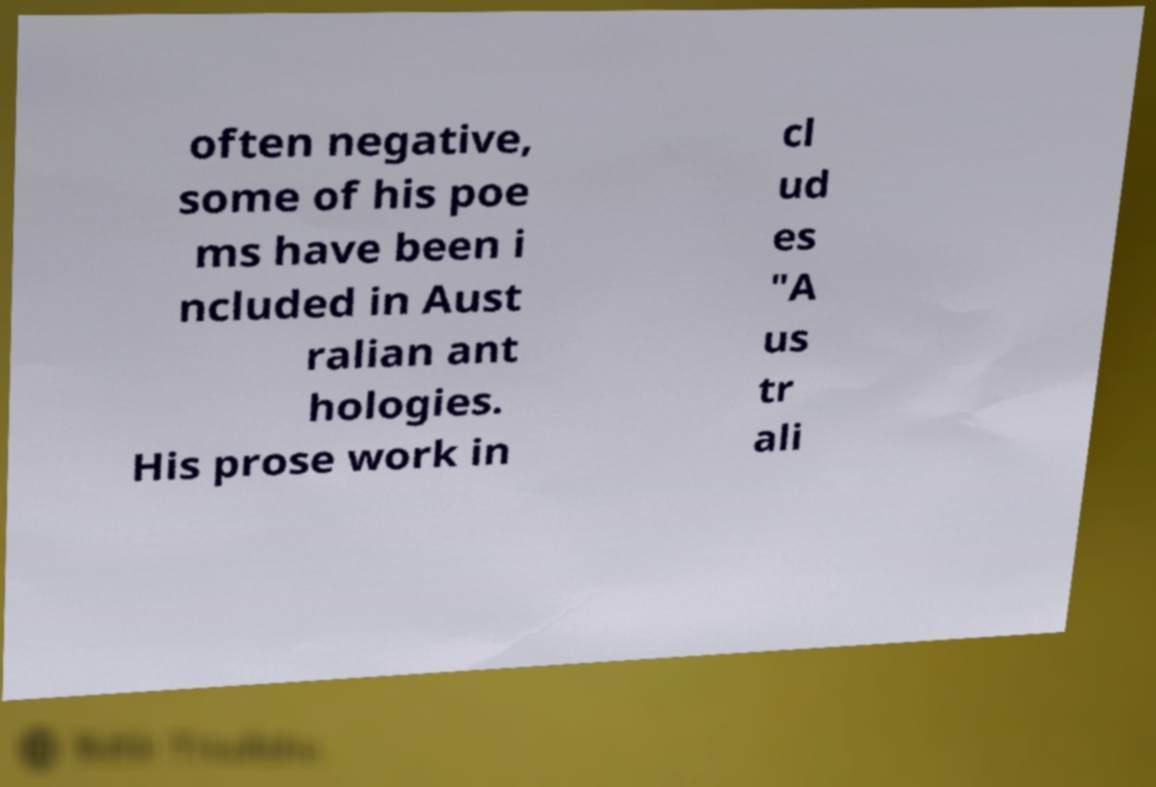Can you accurately transcribe the text from the provided image for me? often negative, some of his poe ms have been i ncluded in Aust ralian ant hologies. His prose work in cl ud es "A us tr ali 